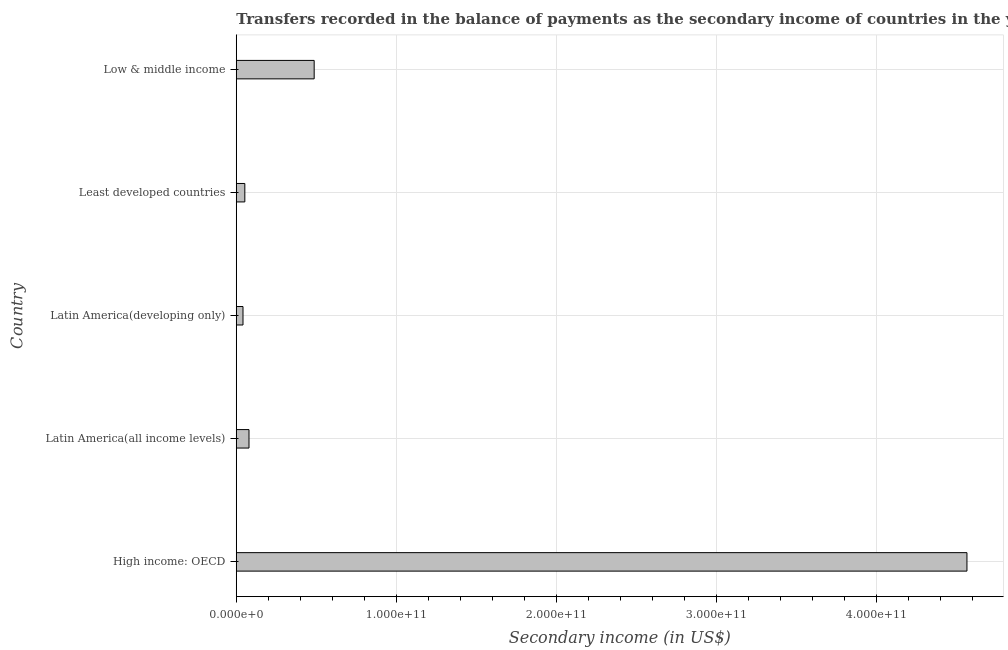What is the title of the graph?
Provide a short and direct response. Transfers recorded in the balance of payments as the secondary income of countries in the year 2009. What is the label or title of the X-axis?
Your response must be concise. Secondary income (in US$). What is the label or title of the Y-axis?
Provide a succinct answer. Country. What is the amount of secondary income in Least developed countries?
Give a very brief answer. 5.36e+09. Across all countries, what is the maximum amount of secondary income?
Your response must be concise. 4.56e+11. Across all countries, what is the minimum amount of secondary income?
Your response must be concise. 4.22e+09. In which country was the amount of secondary income maximum?
Keep it short and to the point. High income: OECD. In which country was the amount of secondary income minimum?
Provide a succinct answer. Latin America(developing only). What is the sum of the amount of secondary income?
Make the answer very short. 5.23e+11. What is the difference between the amount of secondary income in Latin America(all income levels) and Low & middle income?
Keep it short and to the point. -4.07e+1. What is the average amount of secondary income per country?
Provide a short and direct response. 1.05e+11. What is the median amount of secondary income?
Keep it short and to the point. 7.96e+09. What is the ratio of the amount of secondary income in Latin America(all income levels) to that in Low & middle income?
Give a very brief answer. 0.16. Is the amount of secondary income in Least developed countries less than that in Low & middle income?
Your answer should be very brief. Yes. Is the difference between the amount of secondary income in High income: OECD and Low & middle income greater than the difference between any two countries?
Keep it short and to the point. No. What is the difference between the highest and the second highest amount of secondary income?
Make the answer very short. 4.08e+11. What is the difference between the highest and the lowest amount of secondary income?
Offer a terse response. 4.52e+11. How many bars are there?
Your response must be concise. 5. Are all the bars in the graph horizontal?
Your response must be concise. Yes. How many countries are there in the graph?
Make the answer very short. 5. What is the difference between two consecutive major ticks on the X-axis?
Provide a short and direct response. 1.00e+11. What is the Secondary income (in US$) of High income: OECD?
Provide a succinct answer. 4.56e+11. What is the Secondary income (in US$) of Latin America(all income levels)?
Offer a very short reply. 7.96e+09. What is the Secondary income (in US$) in Latin America(developing only)?
Give a very brief answer. 4.22e+09. What is the Secondary income (in US$) of Least developed countries?
Provide a short and direct response. 5.36e+09. What is the Secondary income (in US$) in Low & middle income?
Make the answer very short. 4.87e+1. What is the difference between the Secondary income (in US$) in High income: OECD and Latin America(all income levels)?
Your answer should be very brief. 4.48e+11. What is the difference between the Secondary income (in US$) in High income: OECD and Latin America(developing only)?
Give a very brief answer. 4.52e+11. What is the difference between the Secondary income (in US$) in High income: OECD and Least developed countries?
Keep it short and to the point. 4.51e+11. What is the difference between the Secondary income (in US$) in High income: OECD and Low & middle income?
Your answer should be very brief. 4.08e+11. What is the difference between the Secondary income (in US$) in Latin America(all income levels) and Latin America(developing only)?
Provide a short and direct response. 3.74e+09. What is the difference between the Secondary income (in US$) in Latin America(all income levels) and Least developed countries?
Your answer should be compact. 2.60e+09. What is the difference between the Secondary income (in US$) in Latin America(all income levels) and Low & middle income?
Keep it short and to the point. -4.07e+1. What is the difference between the Secondary income (in US$) in Latin America(developing only) and Least developed countries?
Offer a very short reply. -1.14e+09. What is the difference between the Secondary income (in US$) in Latin America(developing only) and Low & middle income?
Your answer should be very brief. -4.44e+1. What is the difference between the Secondary income (in US$) in Least developed countries and Low & middle income?
Your response must be concise. -4.33e+1. What is the ratio of the Secondary income (in US$) in High income: OECD to that in Latin America(all income levels)?
Provide a succinct answer. 57.34. What is the ratio of the Secondary income (in US$) in High income: OECD to that in Latin America(developing only)?
Make the answer very short. 108.26. What is the ratio of the Secondary income (in US$) in High income: OECD to that in Least developed countries?
Make the answer very short. 85.2. What is the ratio of the Secondary income (in US$) in High income: OECD to that in Low & middle income?
Your answer should be very brief. 9.38. What is the ratio of the Secondary income (in US$) in Latin America(all income levels) to that in Latin America(developing only)?
Provide a succinct answer. 1.89. What is the ratio of the Secondary income (in US$) in Latin America(all income levels) to that in Least developed countries?
Your answer should be compact. 1.49. What is the ratio of the Secondary income (in US$) in Latin America(all income levels) to that in Low & middle income?
Your answer should be compact. 0.16. What is the ratio of the Secondary income (in US$) in Latin America(developing only) to that in Least developed countries?
Give a very brief answer. 0.79. What is the ratio of the Secondary income (in US$) in Latin America(developing only) to that in Low & middle income?
Give a very brief answer. 0.09. What is the ratio of the Secondary income (in US$) in Least developed countries to that in Low & middle income?
Offer a very short reply. 0.11. 